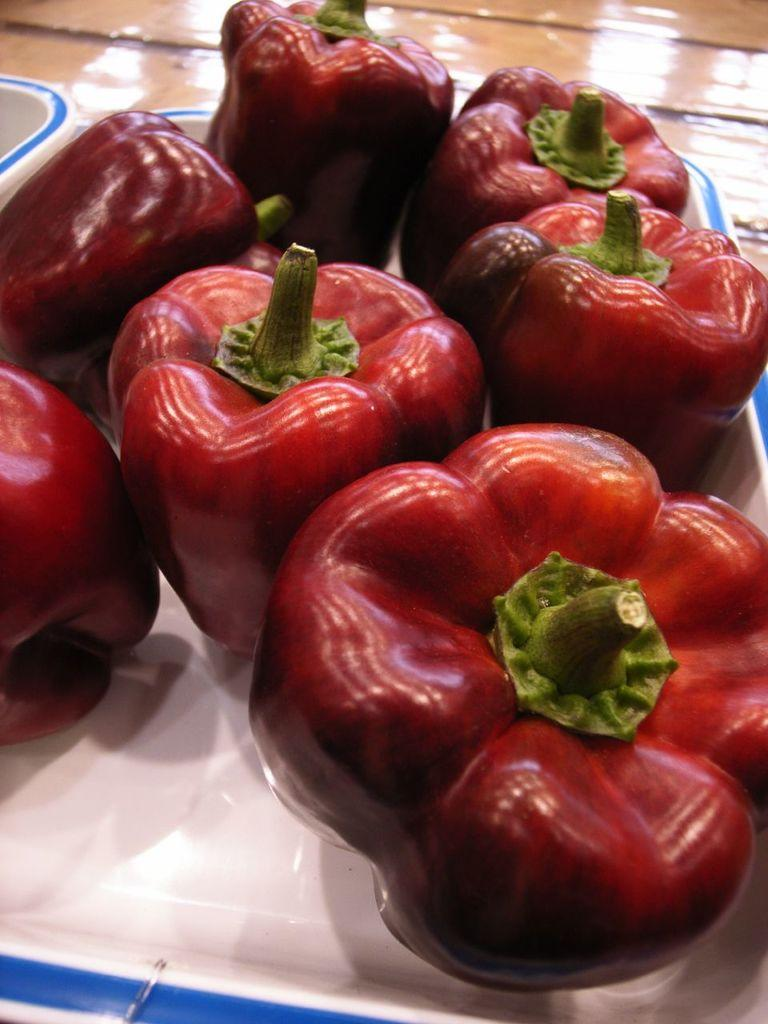What is present on the plate in the image? The plate contains big chilies. Can you describe the size of the chilies on the plate? The chilies on the plate are big. Is there a squirrel helping to prepare the chilies in the image? There is no squirrel present in the image, and no preparation of chilies is depicted. 